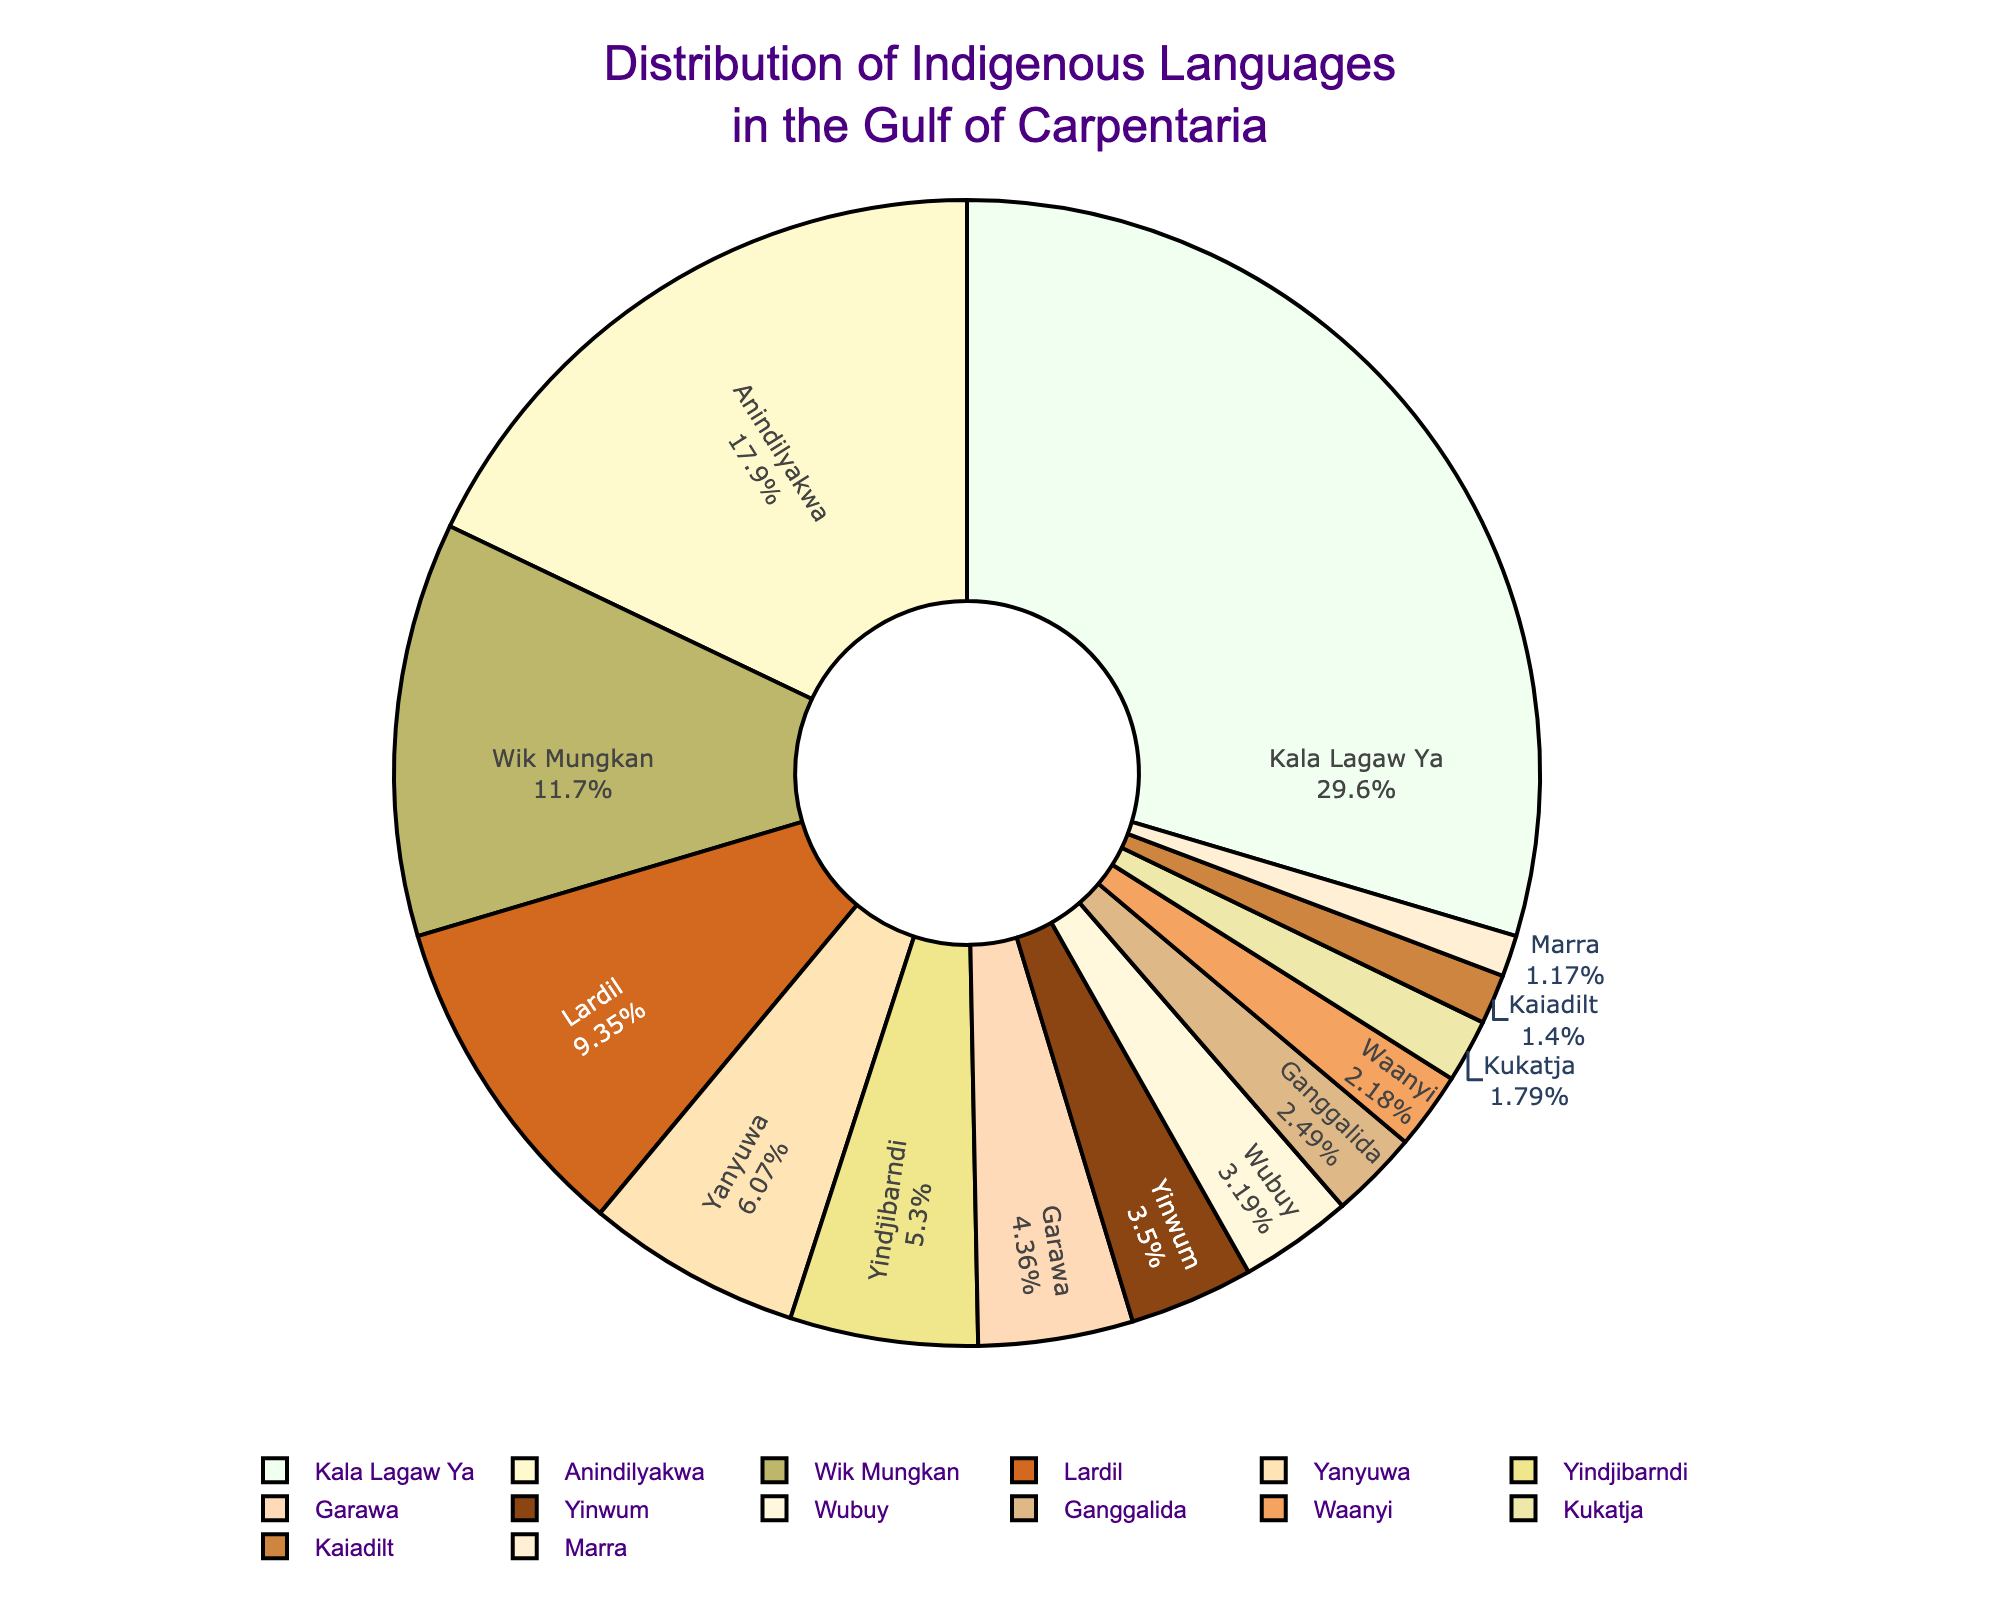Which language has the largest number of speakers? In the pie chart, the largest segment represents the language with the most speakers. This can be identified by looking at the segments' size relative to each other in the chart.
Answer: Kala Lagaw Ya Which language has the smallest number of speakers? In the pie chart, the smallest segment represents the language with the least number of speakers. This can be identified by looking at the segments' size relative to each other in the chart.
Answer: Yinwum How many more speakers does Anindilyakwa have compared to Garawa? From the chart, identify the number of speakers for Anindilyakwa (2300) and Garawa (560). Subtract the number of Garawa speakers from Anindilyakwa speakers: 2300 - 560 = 1740.
Answer: 1740 Which languages have more than 1000 speakers? Identify the segments in the pie chart where the number of speakers exceeds 1000. From the data, these languages are Lardil, Wik Mungkan, Kala Lagaw Ya, and Anindilyakwa.
Answer: Lardil, Wik Mungkan, Kala Lagaw Ya, Anindilyakwa What percentage of the total speakers does Yanyuwa represent? The pie chart shows the percentage next to each segment. Locate the Yanyuwa segment and note the percentage displayed. This value represents the proportion of Yanyuwa speakers relative to the total speaker count.
Answer: To be determined from chart's % Which two languages combined have the same number of speakers as Kala Lagaw Ya? From the data, determine the speakers for various languages and find combinations that sum to 3800. The most direct combination is Anindilyakwa (2300) and Wik Mungkan (1500): 2300 + 1500 = 3800.
Answer: Anindilyakwa and Wik Mungkan What is the difference in the number of speakers between Lardil and Yindjibarndi? Identify the number of speakers for Lardil (1200) and Yindjibarndi (680). Subtract the number of Yindjibarndi speakers from Lardil speakers: 1200 - 680 = 520.
Answer: 520 Which color represents the Ganggalida language segment? Look for the segment labeled Ganggalida in the pie chart and identify its corresponding color.
Answer: To be determined from chart's colors What is the combined percentage of speakers for Yinwum, Waanyi, and Kukatja? Identify the individual percentages for Yinwum, Waanyi, and Kukatja from the pie chart and add them together.
Answer: To be determined from chart's % How many languages have fewer than 500 speakers? Count the segments in the pie chart where the number of speakers is less than 500. From the data, these languages are Yinwum, Kaiadilt, Ganggalida, Waanyi, Marra, and Kukatja.
Answer: 6 